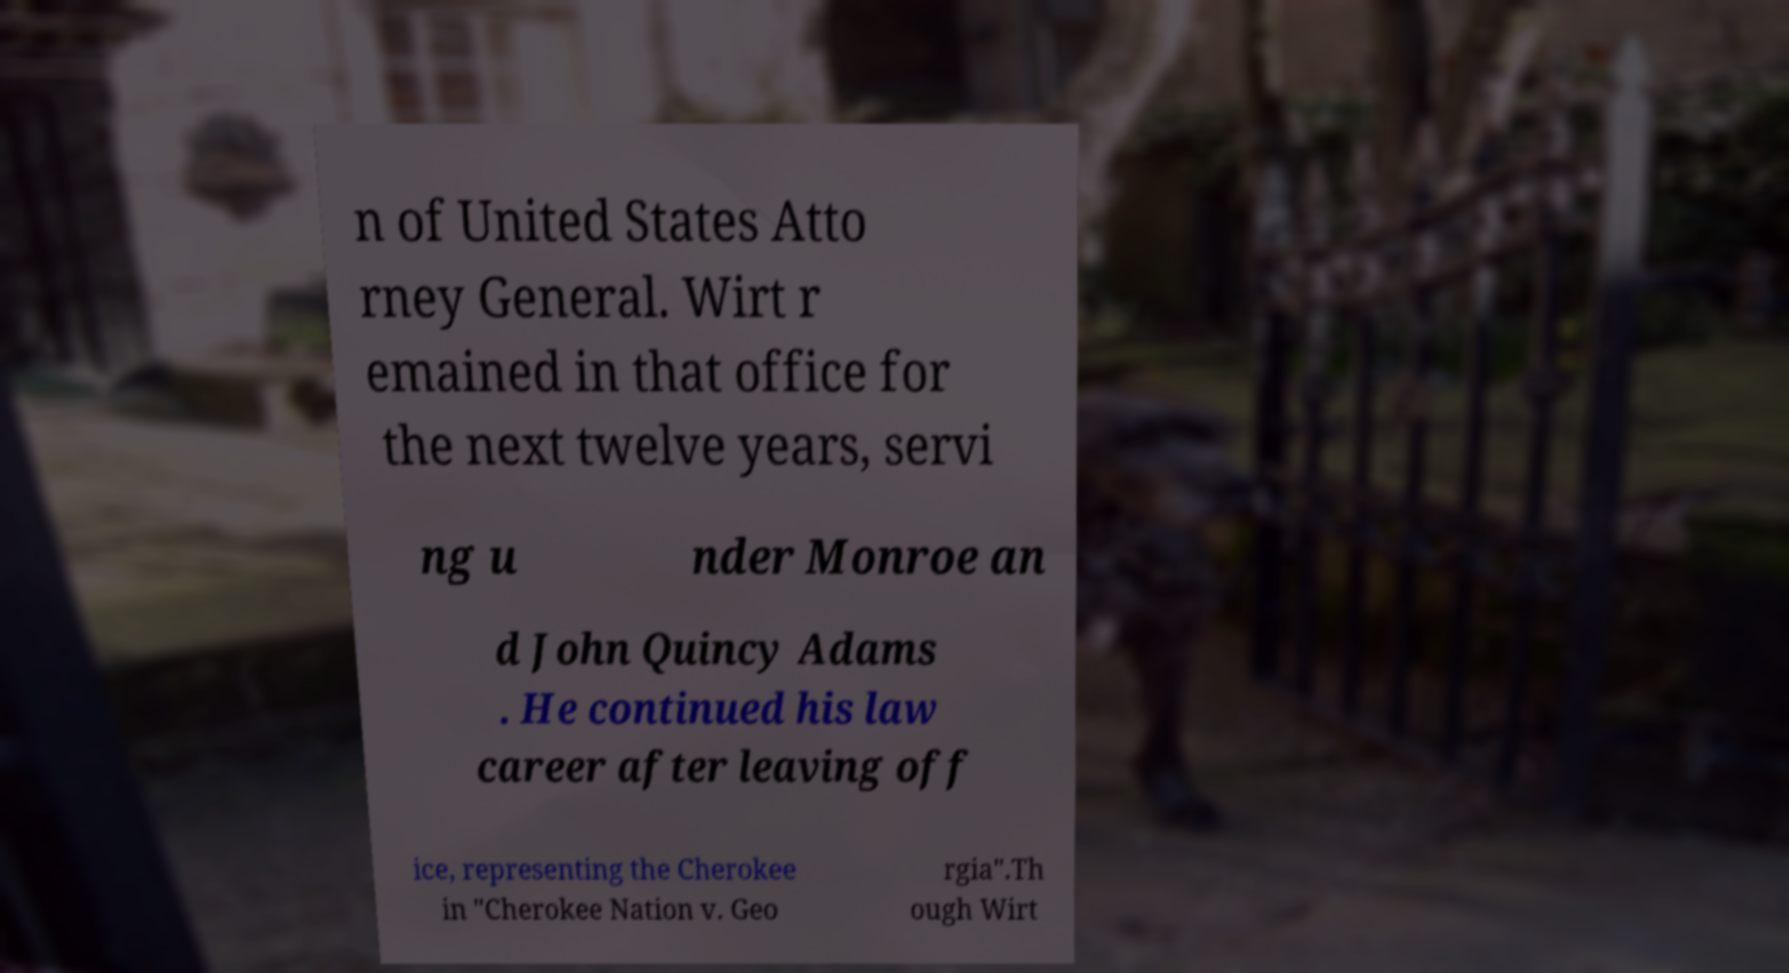For documentation purposes, I need the text within this image transcribed. Could you provide that? n of United States Atto rney General. Wirt r emained in that office for the next twelve years, servi ng u nder Monroe an d John Quincy Adams . He continued his law career after leaving off ice, representing the Cherokee in "Cherokee Nation v. Geo rgia".Th ough Wirt 